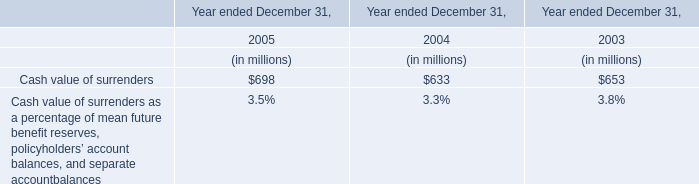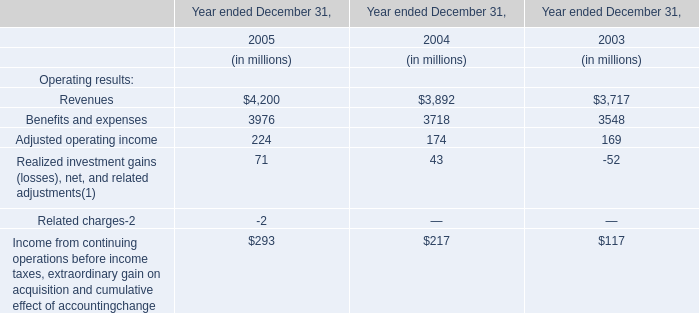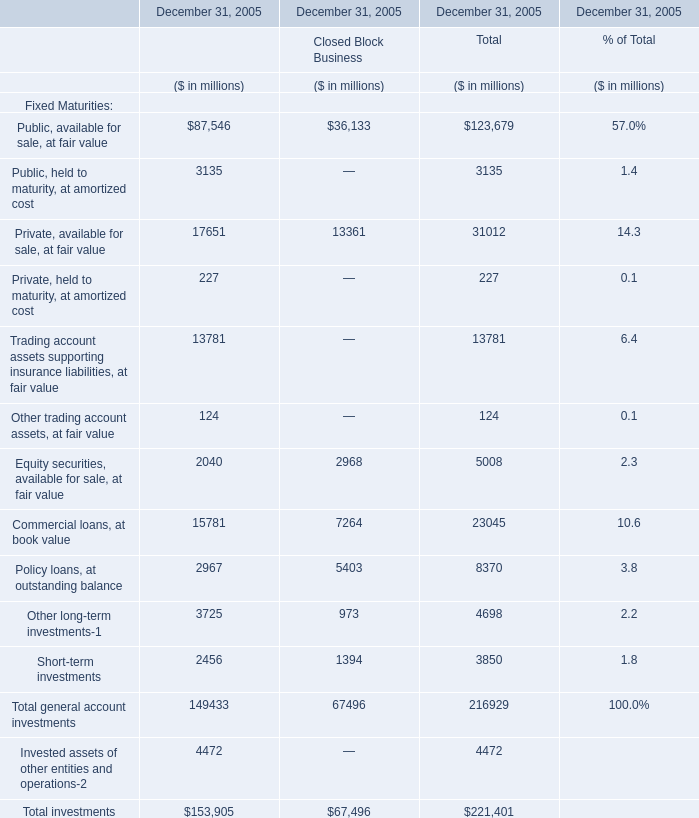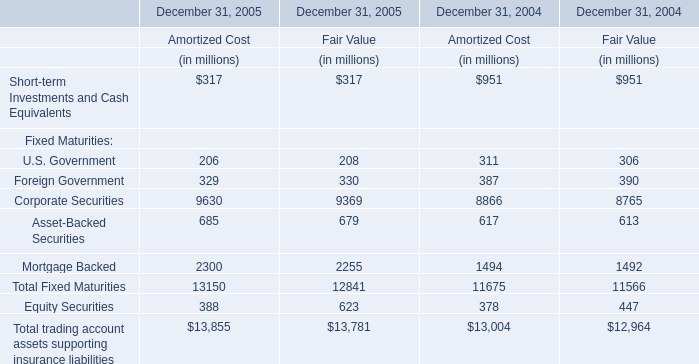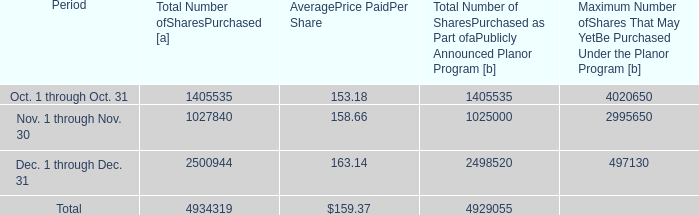What's the average of the Cash value of surrenders in the years where Realized investment gains (losses), net, and related adjustments(1) for Operating results is positive? (in million) 
Computations: ((698 + 633) / 2)
Answer: 665.5. 